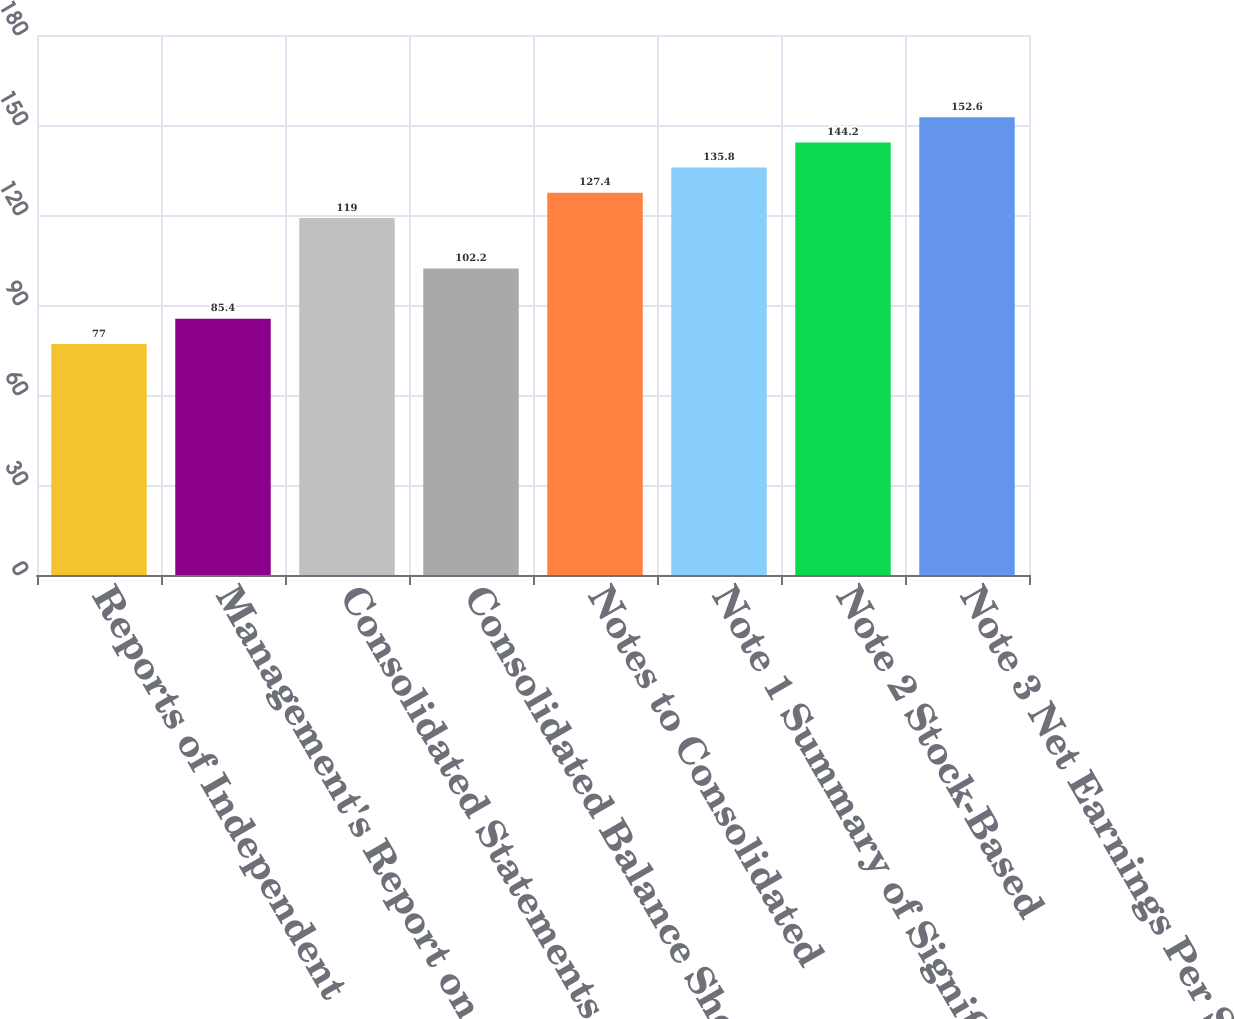Convert chart to OTSL. <chart><loc_0><loc_0><loc_500><loc_500><bar_chart><fcel>Reports of Independent<fcel>Management's Report on<fcel>Consolidated Statements of<fcel>Consolidated Balance Sheets<fcel>Notes to Consolidated<fcel>Note 1 Summary of Significant<fcel>Note 2 Stock-Based<fcel>Note 3 Net Earnings Per Share<nl><fcel>77<fcel>85.4<fcel>119<fcel>102.2<fcel>127.4<fcel>135.8<fcel>144.2<fcel>152.6<nl></chart> 